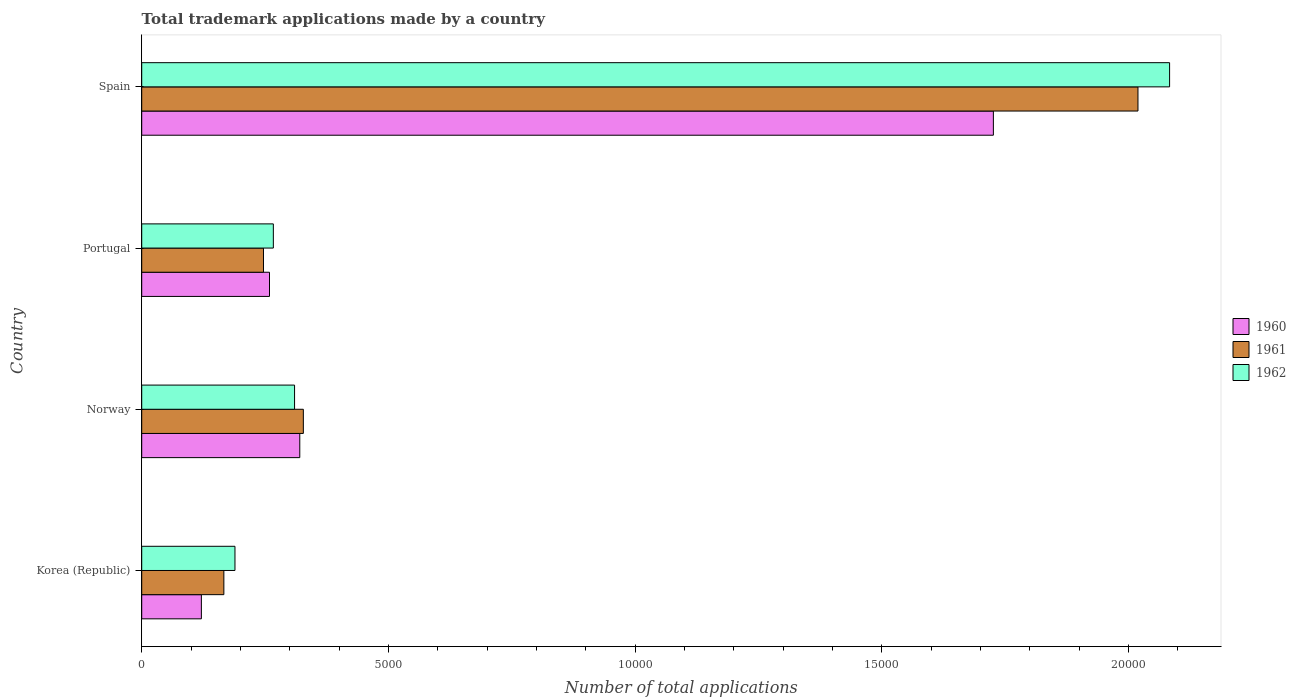How many groups of bars are there?
Your answer should be compact. 4. Are the number of bars per tick equal to the number of legend labels?
Make the answer very short. Yes. Are the number of bars on each tick of the Y-axis equal?
Your answer should be very brief. Yes. How many bars are there on the 2nd tick from the top?
Provide a succinct answer. 3. What is the number of applications made by in 1961 in Norway?
Offer a terse response. 3276. Across all countries, what is the maximum number of applications made by in 1961?
Your answer should be compact. 2.02e+04. Across all countries, what is the minimum number of applications made by in 1960?
Offer a very short reply. 1209. In which country was the number of applications made by in 1961 minimum?
Give a very brief answer. Korea (Republic). What is the total number of applications made by in 1961 in the graph?
Offer a terse response. 2.76e+04. What is the difference between the number of applications made by in 1961 in Norway and that in Spain?
Ensure brevity in your answer.  -1.69e+04. What is the difference between the number of applications made by in 1960 in Norway and the number of applications made by in 1962 in Portugal?
Your response must be concise. 536. What is the average number of applications made by in 1962 per country?
Make the answer very short. 7122.75. What is the difference between the number of applications made by in 1960 and number of applications made by in 1961 in Norway?
Keep it short and to the point. -72. In how many countries, is the number of applications made by in 1962 greater than 9000 ?
Provide a succinct answer. 1. What is the ratio of the number of applications made by in 1961 in Norway to that in Portugal?
Offer a very short reply. 1.33. Is the difference between the number of applications made by in 1960 in Korea (Republic) and Portugal greater than the difference between the number of applications made by in 1961 in Korea (Republic) and Portugal?
Your response must be concise. No. What is the difference between the highest and the second highest number of applications made by in 1961?
Keep it short and to the point. 1.69e+04. What is the difference between the highest and the lowest number of applications made by in 1961?
Give a very brief answer. 1.85e+04. In how many countries, is the number of applications made by in 1962 greater than the average number of applications made by in 1962 taken over all countries?
Give a very brief answer. 1. What does the 2nd bar from the bottom in Norway represents?
Make the answer very short. 1961. Is it the case that in every country, the sum of the number of applications made by in 1960 and number of applications made by in 1961 is greater than the number of applications made by in 1962?
Offer a very short reply. Yes. How many bars are there?
Provide a short and direct response. 12. Are all the bars in the graph horizontal?
Provide a succinct answer. Yes. How many countries are there in the graph?
Make the answer very short. 4. Are the values on the major ticks of X-axis written in scientific E-notation?
Offer a very short reply. No. Does the graph contain any zero values?
Provide a succinct answer. No. Where does the legend appear in the graph?
Provide a short and direct response. Center right. What is the title of the graph?
Provide a short and direct response. Total trademark applications made by a country. What is the label or title of the X-axis?
Provide a succinct answer. Number of total applications. What is the Number of total applications in 1960 in Korea (Republic)?
Offer a very short reply. 1209. What is the Number of total applications in 1961 in Korea (Republic)?
Keep it short and to the point. 1665. What is the Number of total applications in 1962 in Korea (Republic)?
Your response must be concise. 1890. What is the Number of total applications in 1960 in Norway?
Your answer should be compact. 3204. What is the Number of total applications in 1961 in Norway?
Your response must be concise. 3276. What is the Number of total applications in 1962 in Norway?
Offer a terse response. 3098. What is the Number of total applications in 1960 in Portugal?
Offer a very short reply. 2590. What is the Number of total applications in 1961 in Portugal?
Your answer should be very brief. 2468. What is the Number of total applications of 1962 in Portugal?
Offer a very short reply. 2668. What is the Number of total applications of 1960 in Spain?
Provide a short and direct response. 1.73e+04. What is the Number of total applications in 1961 in Spain?
Provide a succinct answer. 2.02e+04. What is the Number of total applications in 1962 in Spain?
Offer a terse response. 2.08e+04. Across all countries, what is the maximum Number of total applications of 1960?
Your answer should be compact. 1.73e+04. Across all countries, what is the maximum Number of total applications in 1961?
Provide a short and direct response. 2.02e+04. Across all countries, what is the maximum Number of total applications of 1962?
Provide a short and direct response. 2.08e+04. Across all countries, what is the minimum Number of total applications of 1960?
Provide a short and direct response. 1209. Across all countries, what is the minimum Number of total applications in 1961?
Offer a very short reply. 1665. Across all countries, what is the minimum Number of total applications in 1962?
Provide a succinct answer. 1890. What is the total Number of total applications of 1960 in the graph?
Offer a terse response. 2.43e+04. What is the total Number of total applications in 1961 in the graph?
Keep it short and to the point. 2.76e+04. What is the total Number of total applications in 1962 in the graph?
Provide a short and direct response. 2.85e+04. What is the difference between the Number of total applications in 1960 in Korea (Republic) and that in Norway?
Offer a terse response. -1995. What is the difference between the Number of total applications of 1961 in Korea (Republic) and that in Norway?
Give a very brief answer. -1611. What is the difference between the Number of total applications in 1962 in Korea (Republic) and that in Norway?
Your answer should be compact. -1208. What is the difference between the Number of total applications of 1960 in Korea (Republic) and that in Portugal?
Make the answer very short. -1381. What is the difference between the Number of total applications in 1961 in Korea (Republic) and that in Portugal?
Your answer should be compact. -803. What is the difference between the Number of total applications in 1962 in Korea (Republic) and that in Portugal?
Keep it short and to the point. -778. What is the difference between the Number of total applications of 1960 in Korea (Republic) and that in Spain?
Your response must be concise. -1.61e+04. What is the difference between the Number of total applications in 1961 in Korea (Republic) and that in Spain?
Your answer should be compact. -1.85e+04. What is the difference between the Number of total applications in 1962 in Korea (Republic) and that in Spain?
Provide a succinct answer. -1.89e+04. What is the difference between the Number of total applications of 1960 in Norway and that in Portugal?
Your response must be concise. 614. What is the difference between the Number of total applications of 1961 in Norway and that in Portugal?
Give a very brief answer. 808. What is the difference between the Number of total applications of 1962 in Norway and that in Portugal?
Your answer should be very brief. 430. What is the difference between the Number of total applications of 1960 in Norway and that in Spain?
Give a very brief answer. -1.41e+04. What is the difference between the Number of total applications in 1961 in Norway and that in Spain?
Your answer should be very brief. -1.69e+04. What is the difference between the Number of total applications of 1962 in Norway and that in Spain?
Your answer should be very brief. -1.77e+04. What is the difference between the Number of total applications in 1960 in Portugal and that in Spain?
Keep it short and to the point. -1.47e+04. What is the difference between the Number of total applications of 1961 in Portugal and that in Spain?
Provide a short and direct response. -1.77e+04. What is the difference between the Number of total applications of 1962 in Portugal and that in Spain?
Keep it short and to the point. -1.82e+04. What is the difference between the Number of total applications in 1960 in Korea (Republic) and the Number of total applications in 1961 in Norway?
Give a very brief answer. -2067. What is the difference between the Number of total applications of 1960 in Korea (Republic) and the Number of total applications of 1962 in Norway?
Offer a very short reply. -1889. What is the difference between the Number of total applications in 1961 in Korea (Republic) and the Number of total applications in 1962 in Norway?
Make the answer very short. -1433. What is the difference between the Number of total applications in 1960 in Korea (Republic) and the Number of total applications in 1961 in Portugal?
Your answer should be very brief. -1259. What is the difference between the Number of total applications of 1960 in Korea (Republic) and the Number of total applications of 1962 in Portugal?
Give a very brief answer. -1459. What is the difference between the Number of total applications of 1961 in Korea (Republic) and the Number of total applications of 1962 in Portugal?
Provide a short and direct response. -1003. What is the difference between the Number of total applications of 1960 in Korea (Republic) and the Number of total applications of 1961 in Spain?
Ensure brevity in your answer.  -1.90e+04. What is the difference between the Number of total applications of 1960 in Korea (Republic) and the Number of total applications of 1962 in Spain?
Make the answer very short. -1.96e+04. What is the difference between the Number of total applications in 1961 in Korea (Republic) and the Number of total applications in 1962 in Spain?
Your response must be concise. -1.92e+04. What is the difference between the Number of total applications of 1960 in Norway and the Number of total applications of 1961 in Portugal?
Offer a very short reply. 736. What is the difference between the Number of total applications of 1960 in Norway and the Number of total applications of 1962 in Portugal?
Ensure brevity in your answer.  536. What is the difference between the Number of total applications of 1961 in Norway and the Number of total applications of 1962 in Portugal?
Provide a short and direct response. 608. What is the difference between the Number of total applications of 1960 in Norway and the Number of total applications of 1961 in Spain?
Ensure brevity in your answer.  -1.70e+04. What is the difference between the Number of total applications of 1960 in Norway and the Number of total applications of 1962 in Spain?
Your answer should be very brief. -1.76e+04. What is the difference between the Number of total applications of 1961 in Norway and the Number of total applications of 1962 in Spain?
Make the answer very short. -1.76e+04. What is the difference between the Number of total applications in 1960 in Portugal and the Number of total applications in 1961 in Spain?
Provide a succinct answer. -1.76e+04. What is the difference between the Number of total applications of 1960 in Portugal and the Number of total applications of 1962 in Spain?
Provide a succinct answer. -1.82e+04. What is the difference between the Number of total applications in 1961 in Portugal and the Number of total applications in 1962 in Spain?
Your answer should be very brief. -1.84e+04. What is the average Number of total applications in 1960 per country?
Offer a terse response. 6066.5. What is the average Number of total applications in 1961 per country?
Provide a short and direct response. 6900.75. What is the average Number of total applications of 1962 per country?
Offer a very short reply. 7122.75. What is the difference between the Number of total applications in 1960 and Number of total applications in 1961 in Korea (Republic)?
Ensure brevity in your answer.  -456. What is the difference between the Number of total applications of 1960 and Number of total applications of 1962 in Korea (Republic)?
Offer a terse response. -681. What is the difference between the Number of total applications in 1961 and Number of total applications in 1962 in Korea (Republic)?
Provide a succinct answer. -225. What is the difference between the Number of total applications in 1960 and Number of total applications in 1961 in Norway?
Ensure brevity in your answer.  -72. What is the difference between the Number of total applications of 1960 and Number of total applications of 1962 in Norway?
Offer a terse response. 106. What is the difference between the Number of total applications of 1961 and Number of total applications of 1962 in Norway?
Provide a succinct answer. 178. What is the difference between the Number of total applications of 1960 and Number of total applications of 1961 in Portugal?
Ensure brevity in your answer.  122. What is the difference between the Number of total applications of 1960 and Number of total applications of 1962 in Portugal?
Make the answer very short. -78. What is the difference between the Number of total applications in 1961 and Number of total applications in 1962 in Portugal?
Offer a very short reply. -200. What is the difference between the Number of total applications in 1960 and Number of total applications in 1961 in Spain?
Ensure brevity in your answer.  -2931. What is the difference between the Number of total applications in 1960 and Number of total applications in 1962 in Spain?
Provide a succinct answer. -3572. What is the difference between the Number of total applications of 1961 and Number of total applications of 1962 in Spain?
Provide a short and direct response. -641. What is the ratio of the Number of total applications in 1960 in Korea (Republic) to that in Norway?
Keep it short and to the point. 0.38. What is the ratio of the Number of total applications in 1961 in Korea (Republic) to that in Norway?
Give a very brief answer. 0.51. What is the ratio of the Number of total applications of 1962 in Korea (Republic) to that in Norway?
Your answer should be compact. 0.61. What is the ratio of the Number of total applications of 1960 in Korea (Republic) to that in Portugal?
Offer a terse response. 0.47. What is the ratio of the Number of total applications in 1961 in Korea (Republic) to that in Portugal?
Keep it short and to the point. 0.67. What is the ratio of the Number of total applications of 1962 in Korea (Republic) to that in Portugal?
Offer a very short reply. 0.71. What is the ratio of the Number of total applications in 1960 in Korea (Republic) to that in Spain?
Provide a short and direct response. 0.07. What is the ratio of the Number of total applications in 1961 in Korea (Republic) to that in Spain?
Make the answer very short. 0.08. What is the ratio of the Number of total applications in 1962 in Korea (Republic) to that in Spain?
Provide a short and direct response. 0.09. What is the ratio of the Number of total applications in 1960 in Norway to that in Portugal?
Give a very brief answer. 1.24. What is the ratio of the Number of total applications of 1961 in Norway to that in Portugal?
Ensure brevity in your answer.  1.33. What is the ratio of the Number of total applications in 1962 in Norway to that in Portugal?
Make the answer very short. 1.16. What is the ratio of the Number of total applications in 1960 in Norway to that in Spain?
Keep it short and to the point. 0.19. What is the ratio of the Number of total applications in 1961 in Norway to that in Spain?
Your answer should be very brief. 0.16. What is the ratio of the Number of total applications in 1962 in Norway to that in Spain?
Your answer should be compact. 0.15. What is the ratio of the Number of total applications in 1960 in Portugal to that in Spain?
Offer a terse response. 0.15. What is the ratio of the Number of total applications of 1961 in Portugal to that in Spain?
Provide a succinct answer. 0.12. What is the ratio of the Number of total applications in 1962 in Portugal to that in Spain?
Keep it short and to the point. 0.13. What is the difference between the highest and the second highest Number of total applications in 1960?
Your answer should be very brief. 1.41e+04. What is the difference between the highest and the second highest Number of total applications in 1961?
Ensure brevity in your answer.  1.69e+04. What is the difference between the highest and the second highest Number of total applications of 1962?
Your answer should be compact. 1.77e+04. What is the difference between the highest and the lowest Number of total applications in 1960?
Provide a succinct answer. 1.61e+04. What is the difference between the highest and the lowest Number of total applications of 1961?
Make the answer very short. 1.85e+04. What is the difference between the highest and the lowest Number of total applications of 1962?
Your response must be concise. 1.89e+04. 